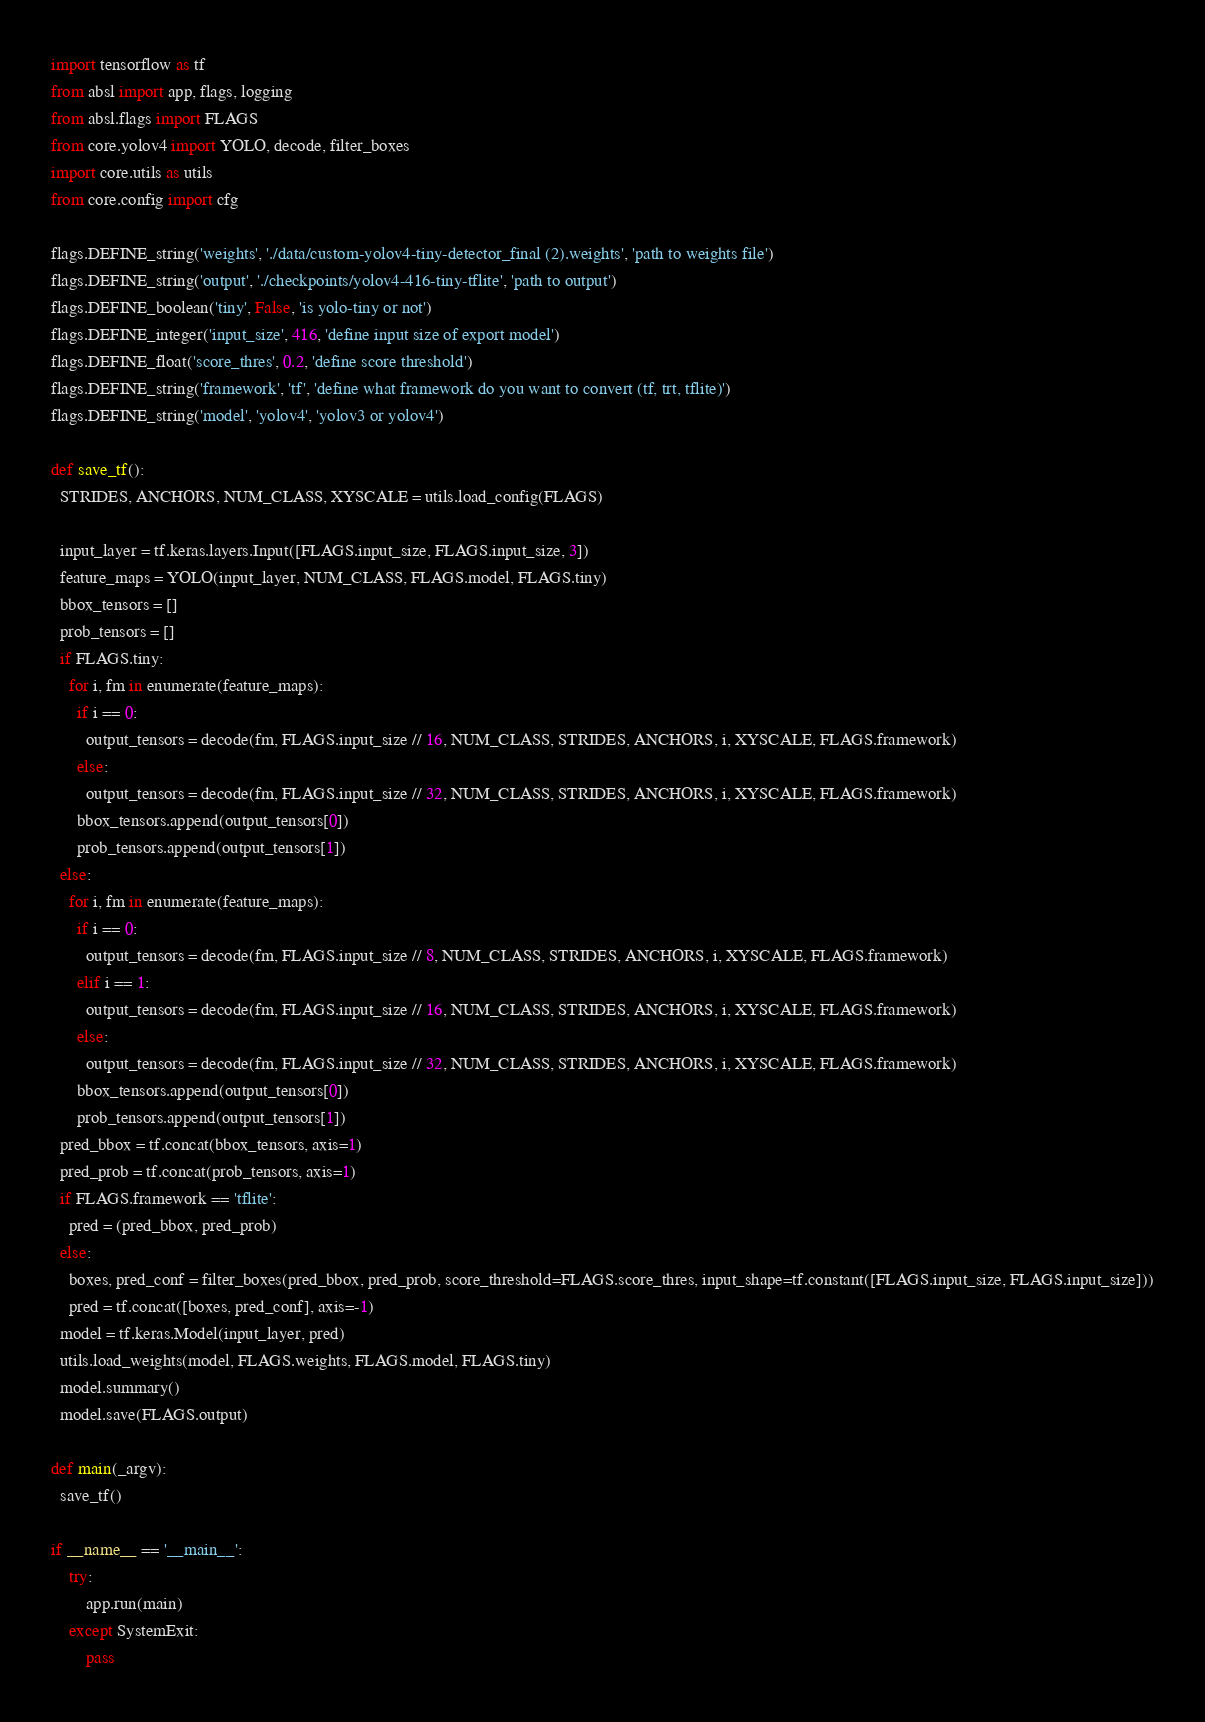<code> <loc_0><loc_0><loc_500><loc_500><_Python_>import tensorflow as tf
from absl import app, flags, logging
from absl.flags import FLAGS
from core.yolov4 import YOLO, decode, filter_boxes
import core.utils as utils
from core.config import cfg

flags.DEFINE_string('weights', './data/custom-yolov4-tiny-detector_final (2).weights', 'path to weights file')
flags.DEFINE_string('output', './checkpoints/yolov4-416-tiny-tflite', 'path to output')
flags.DEFINE_boolean('tiny', False, 'is yolo-tiny or not')
flags.DEFINE_integer('input_size', 416, 'define input size of export model')
flags.DEFINE_float('score_thres', 0.2, 'define score threshold')
flags.DEFINE_string('framework', 'tf', 'define what framework do you want to convert (tf, trt, tflite)')
flags.DEFINE_string('model', 'yolov4', 'yolov3 or yolov4')

def save_tf():
  STRIDES, ANCHORS, NUM_CLASS, XYSCALE = utils.load_config(FLAGS)

  input_layer = tf.keras.layers.Input([FLAGS.input_size, FLAGS.input_size, 3])
  feature_maps = YOLO(input_layer, NUM_CLASS, FLAGS.model, FLAGS.tiny)
  bbox_tensors = []
  prob_tensors = []
  if FLAGS.tiny:
    for i, fm in enumerate(feature_maps):
      if i == 0:
        output_tensors = decode(fm, FLAGS.input_size // 16, NUM_CLASS, STRIDES, ANCHORS, i, XYSCALE, FLAGS.framework)
      else:
        output_tensors = decode(fm, FLAGS.input_size // 32, NUM_CLASS, STRIDES, ANCHORS, i, XYSCALE, FLAGS.framework)
      bbox_tensors.append(output_tensors[0])
      prob_tensors.append(output_tensors[1])
  else:
    for i, fm in enumerate(feature_maps):
      if i == 0:
        output_tensors = decode(fm, FLAGS.input_size // 8, NUM_CLASS, STRIDES, ANCHORS, i, XYSCALE, FLAGS.framework)
      elif i == 1:
        output_tensors = decode(fm, FLAGS.input_size // 16, NUM_CLASS, STRIDES, ANCHORS, i, XYSCALE, FLAGS.framework)
      else:
        output_tensors = decode(fm, FLAGS.input_size // 32, NUM_CLASS, STRIDES, ANCHORS, i, XYSCALE, FLAGS.framework)
      bbox_tensors.append(output_tensors[0])
      prob_tensors.append(output_tensors[1])
  pred_bbox = tf.concat(bbox_tensors, axis=1)
  pred_prob = tf.concat(prob_tensors, axis=1)
  if FLAGS.framework == 'tflite':
    pred = (pred_bbox, pred_prob)
  else:
    boxes, pred_conf = filter_boxes(pred_bbox, pred_prob, score_threshold=FLAGS.score_thres, input_shape=tf.constant([FLAGS.input_size, FLAGS.input_size]))
    pred = tf.concat([boxes, pred_conf], axis=-1)
  model = tf.keras.Model(input_layer, pred)
  utils.load_weights(model, FLAGS.weights, FLAGS.model, FLAGS.tiny)
  model.summary()
  model.save(FLAGS.output)

def main(_argv):
  save_tf()

if __name__ == '__main__':
    try:
        app.run(main)
    except SystemExit:
        pass
</code> 